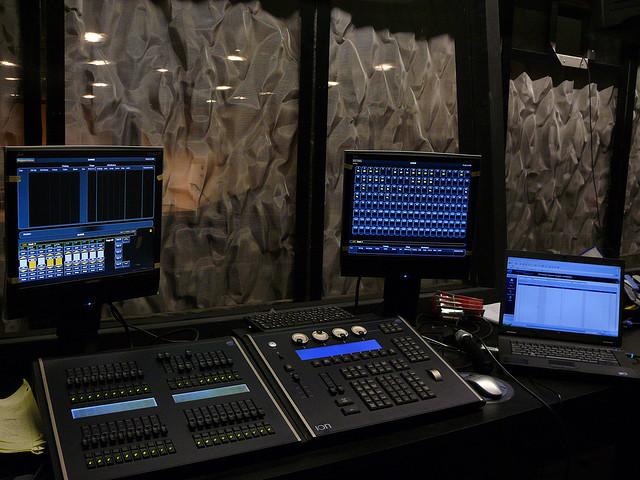Is the equipment turned on?
Write a very short answer. Yes. Is there power in this room?
Short answer required. Yes. What room is this?
Answer briefly. Recording studio. 